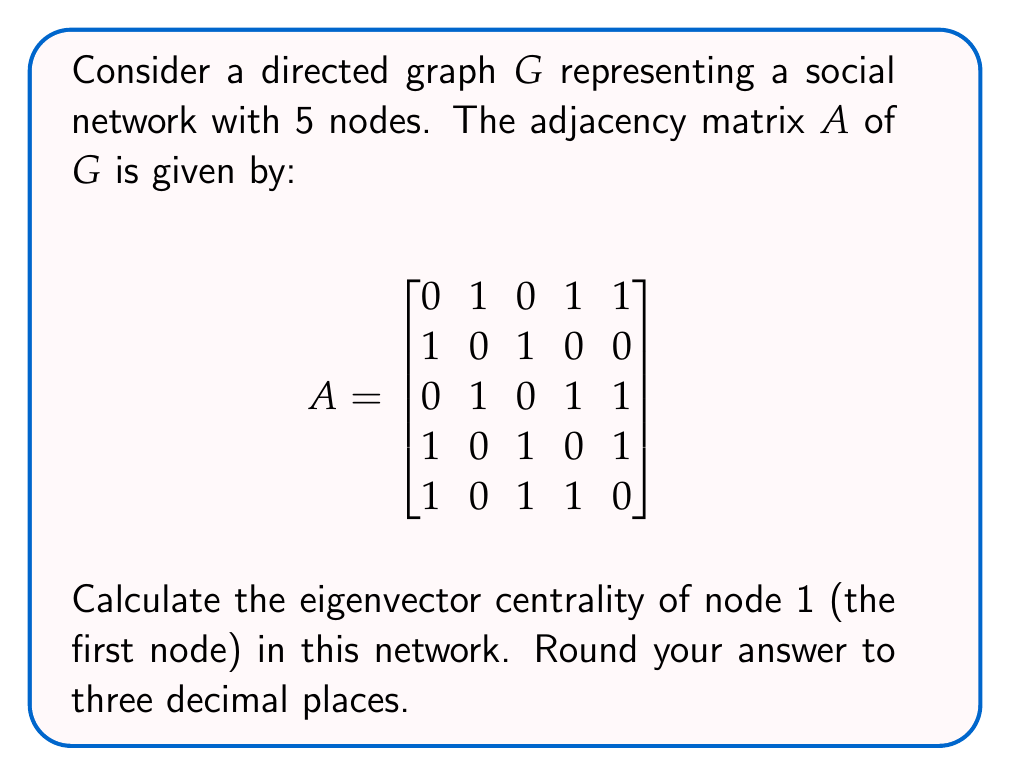Solve this math problem. To calculate the eigenvector centrality, we need to follow these steps:

1) First, we need to find the largest eigenvalue (λ) and its corresponding eigenvector for the adjacency matrix A.

2) The characteristic equation is:
   $det(A - λI) = 0$

3) Solving this equation (which is complex and can be done using numerical methods), we get the largest eigenvalue:
   $λ_{max} ≈ 2.4815$

4) Now, we need to find the eigenvector $x$ corresponding to this eigenvalue:
   $(A - λ_{max}I)x = 0$

5) Solving this system of equations and normalizing the result, we get the eigenvector:
   $x ≈ [0.4867, 0.3249, 0.4408, 0.4408, 0.4867]^T$

6) The eigenvector centrality of each node is given by its corresponding value in this normalized eigenvector.

7) For node 1, this is the first element of the vector: 0.4867

8) Rounding to three decimal places: 0.487

Therefore, the eigenvector centrality of node 1 is approximately 0.487.
Answer: 0.487 